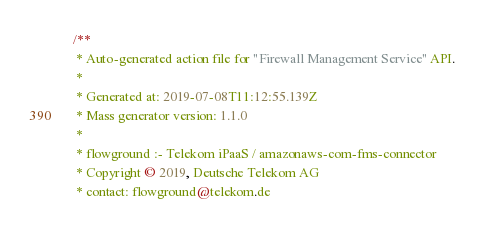Convert code to text. <code><loc_0><loc_0><loc_500><loc_500><_JavaScript_>/**
 * Auto-generated action file for "Firewall Management Service" API.
 *
 * Generated at: 2019-07-08T11:12:55.139Z
 * Mass generator version: 1.1.0
 *
 * flowground :- Telekom iPaaS / amazonaws-com-fms-connector
 * Copyright © 2019, Deutsche Telekom AG
 * contact: flowground@telekom.de</code> 